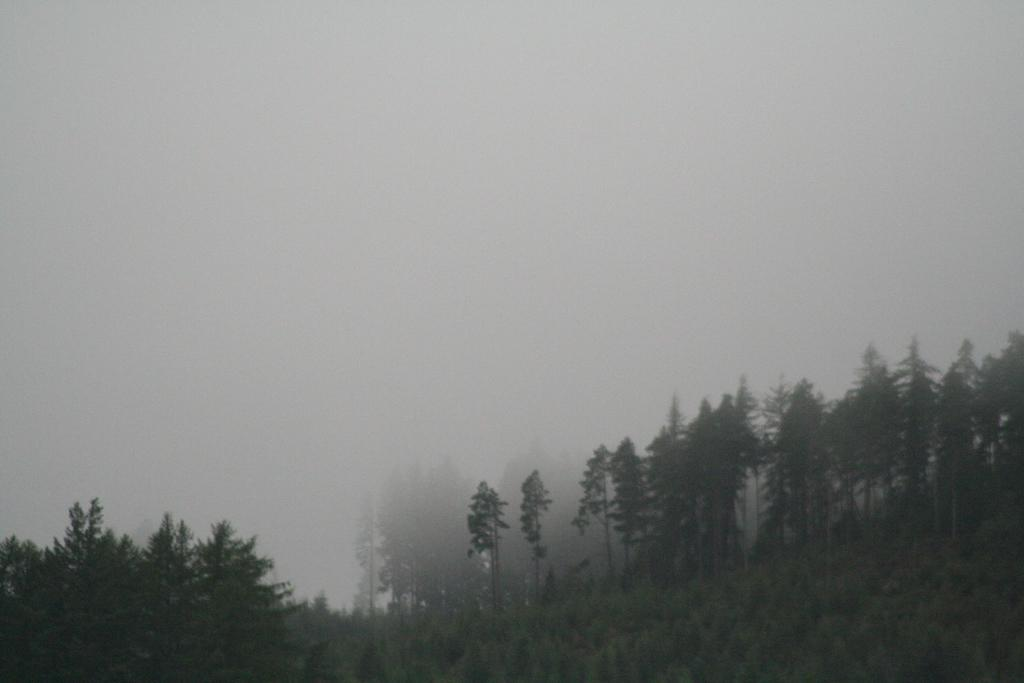What type of vegetation can be seen in the image? There are trees and plants in the image. What is visible at the top of the image? The sky is visible at the top of the image. What month is it in the image? The month cannot be determined from the image, as there is no information about the time of year or any seasonal indicators present. 